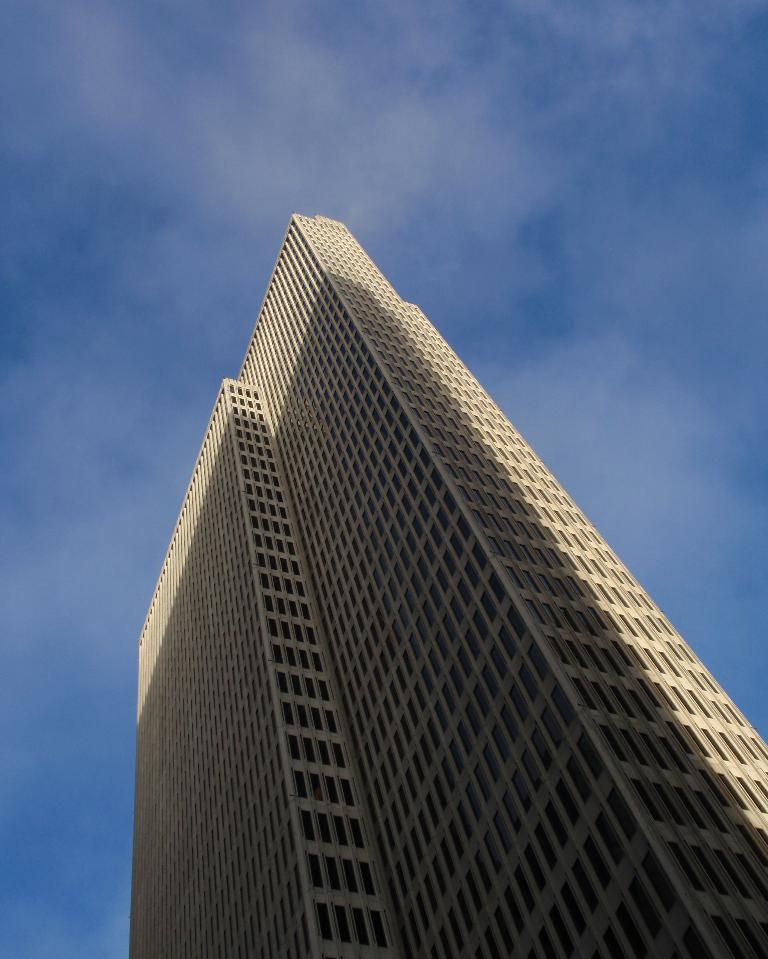What structure is present in the image? There is a building in the image. What can be seen in the background of the image? The sky is visible in the background of the image. What is the condition of the sky in the image? There are clouds in the sky. What type of cushion can be seen on the roof of the building in the image? There is no cushion visible on the roof of the building in the image. What kind of tin is being used to hold the clouds together? There is no tin present in the image; the clouds are naturally occurring in the sky. 